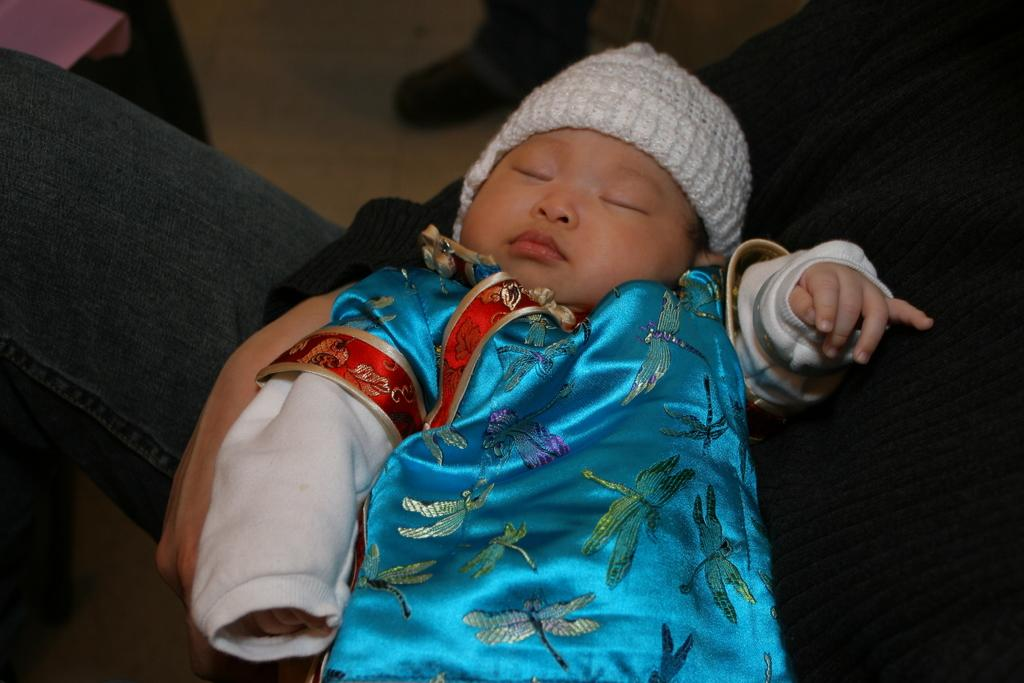What is the main subject of the image? There is a baby in the image. What is the baby doing in the image? The baby is sleeping. What is the baby wearing in the image? The baby is wearing a blue dress. Can you describe the person sitting in the image? Unfortunately, the facts provided do not give any information about the person sitting in the image. What type of orange is the baby holding in the image? There is no orange present in the image; the baby is wearing a blue dress and sleeping. 